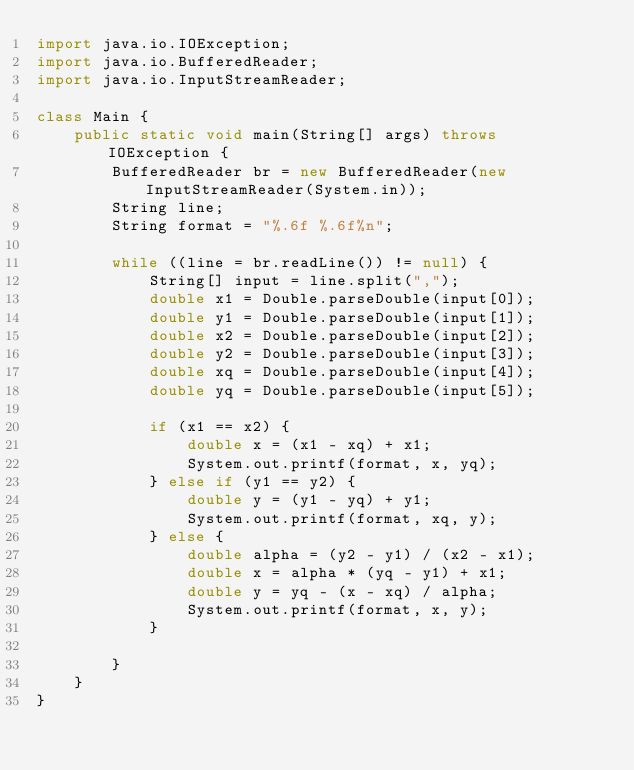<code> <loc_0><loc_0><loc_500><loc_500><_Java_>import java.io.IOException;
import java.io.BufferedReader;
import java.io.InputStreamReader;

class Main {
    public static void main(String[] args) throws IOException {
        BufferedReader br = new BufferedReader(new InputStreamReader(System.in));
        String line;
        String format = "%.6f %.6f%n";

        while ((line = br.readLine()) != null) {
            String[] input = line.split(",");
            double x1 = Double.parseDouble(input[0]);
            double y1 = Double.parseDouble(input[1]);
            double x2 = Double.parseDouble(input[2]);
            double y2 = Double.parseDouble(input[3]);
            double xq = Double.parseDouble(input[4]);
            double yq = Double.parseDouble(input[5]);

            if (x1 == x2) {
                double x = (x1 - xq) + x1;
                System.out.printf(format, x, yq);
            } else if (y1 == y2) {
                double y = (y1 - yq) + y1;
                System.out.printf(format, xq, y);
            } else {
                double alpha = (y2 - y1) / (x2 - x1);
                double x = alpha * (yq - y1) + x1;
                double y = yq - (x - xq) / alpha;
                System.out.printf(format, x, y);
            }

        }
    }
}
</code> 